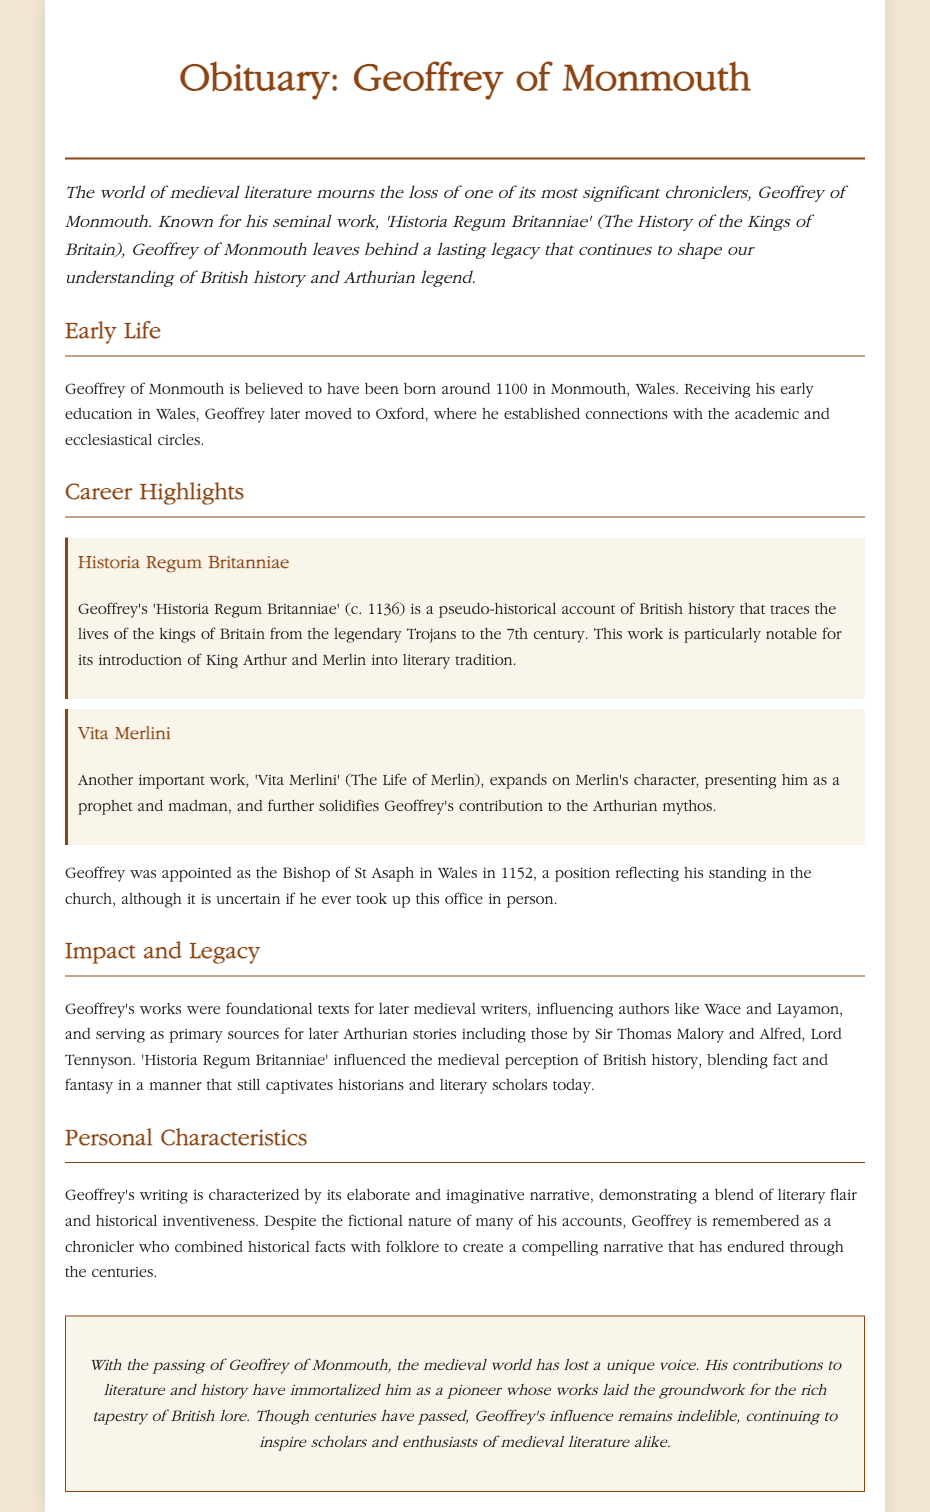What is the title of Geoffrey of Monmouth's seminal work? The title of Geoffrey of Monmouth's seminal work is stated in the document as 'Historia Regum Britanniae'.
Answer: Historia Regum Britanniae In what year was 'Historia Regum Britanniae' published? The document mentions that 'Historia Regum Britanniae' was written around the year 1136.
Answer: 1136 What position was Geoffrey of Monmouth appointed to in 1152? The document indicates that Geoffrey was appointed as the Bishop of St Asaph in Wales in 1152.
Answer: Bishop of St Asaph What mythical characters did Geoffrey introduce into literature? The document notes that Geoffrey introduced King Arthur and Merlin into literary tradition.
Answer: King Arthur and Merlin How did Geoffrey's works influence later writers? The document explains that Geoffrey’s works were foundational texts for later medieval writers such as Wace and Layamon.
Answer: Foundational texts What is significant about Geoffrey's narrative style? The document highlights that Geoffrey's writing is characterized by its elaborate and imaginative narrative.
Answer: Elaborate and imaginative narrative What blend did Geoffrey use in his writings? The document states that Geoffrey combined historical facts with folklore to create a compelling narrative.
Answer: Historical facts and folklore Why is Geoffrey of Monmouth considered a pioneer in literature? The document mentions that Geoffrey's contributions to literature and history laid the groundwork for the rich tapestry of British lore.
Answer: Laid the groundwork for British lore What academic institution did Geoffrey move to after Wales? The document states that Geoffrey later moved to Oxford after receiving his early education in Wales.
Answer: Oxford 